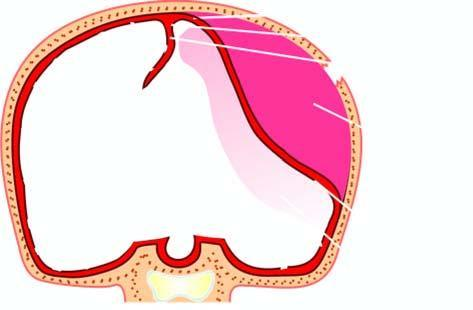what results from rupture of artery following skull fracture resulting in accumulation of arterial blood between the skull and the dura?
Answer the question using a single word or phrase. Epidural haematoma 